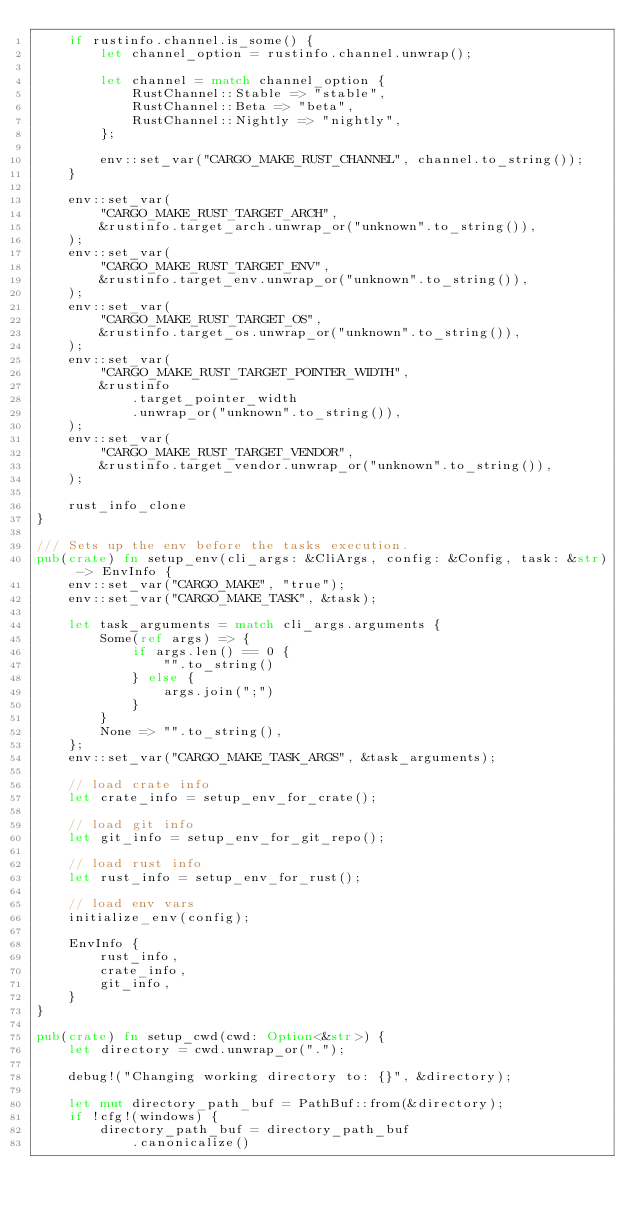Convert code to text. <code><loc_0><loc_0><loc_500><loc_500><_Rust_>    if rustinfo.channel.is_some() {
        let channel_option = rustinfo.channel.unwrap();

        let channel = match channel_option {
            RustChannel::Stable => "stable",
            RustChannel::Beta => "beta",
            RustChannel::Nightly => "nightly",
        };

        env::set_var("CARGO_MAKE_RUST_CHANNEL", channel.to_string());
    }

    env::set_var(
        "CARGO_MAKE_RUST_TARGET_ARCH",
        &rustinfo.target_arch.unwrap_or("unknown".to_string()),
    );
    env::set_var(
        "CARGO_MAKE_RUST_TARGET_ENV",
        &rustinfo.target_env.unwrap_or("unknown".to_string()),
    );
    env::set_var(
        "CARGO_MAKE_RUST_TARGET_OS",
        &rustinfo.target_os.unwrap_or("unknown".to_string()),
    );
    env::set_var(
        "CARGO_MAKE_RUST_TARGET_POINTER_WIDTH",
        &rustinfo
            .target_pointer_width
            .unwrap_or("unknown".to_string()),
    );
    env::set_var(
        "CARGO_MAKE_RUST_TARGET_VENDOR",
        &rustinfo.target_vendor.unwrap_or("unknown".to_string()),
    );

    rust_info_clone
}

/// Sets up the env before the tasks execution.
pub(crate) fn setup_env(cli_args: &CliArgs, config: &Config, task: &str) -> EnvInfo {
    env::set_var("CARGO_MAKE", "true");
    env::set_var("CARGO_MAKE_TASK", &task);

    let task_arguments = match cli_args.arguments {
        Some(ref args) => {
            if args.len() == 0 {
                "".to_string()
            } else {
                args.join(";")
            }
        }
        None => "".to_string(),
    };
    env::set_var("CARGO_MAKE_TASK_ARGS", &task_arguments);

    // load crate info
    let crate_info = setup_env_for_crate();

    // load git info
    let git_info = setup_env_for_git_repo();

    // load rust info
    let rust_info = setup_env_for_rust();

    // load env vars
    initialize_env(config);

    EnvInfo {
        rust_info,
        crate_info,
        git_info,
    }
}

pub(crate) fn setup_cwd(cwd: Option<&str>) {
    let directory = cwd.unwrap_or(".");

    debug!("Changing working directory to: {}", &directory);

    let mut directory_path_buf = PathBuf::from(&directory);
    if !cfg!(windows) {
        directory_path_buf = directory_path_buf
            .canonicalize()</code> 